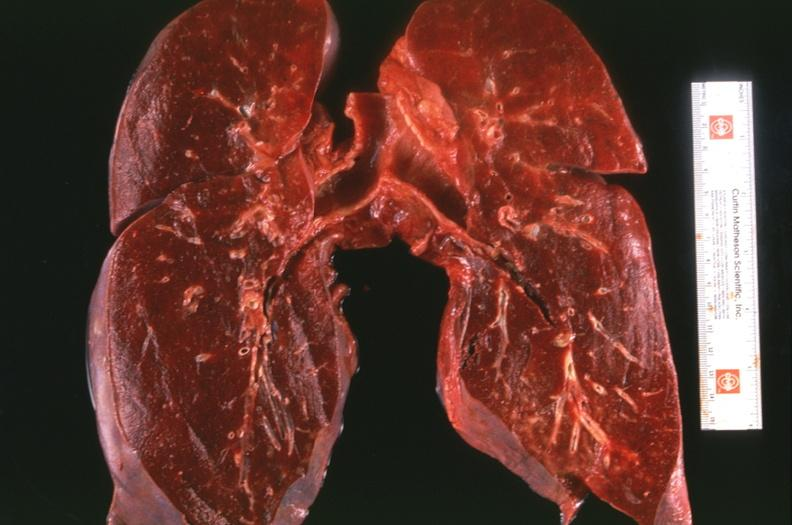s respiratory present?
Answer the question using a single word or phrase. Yes 